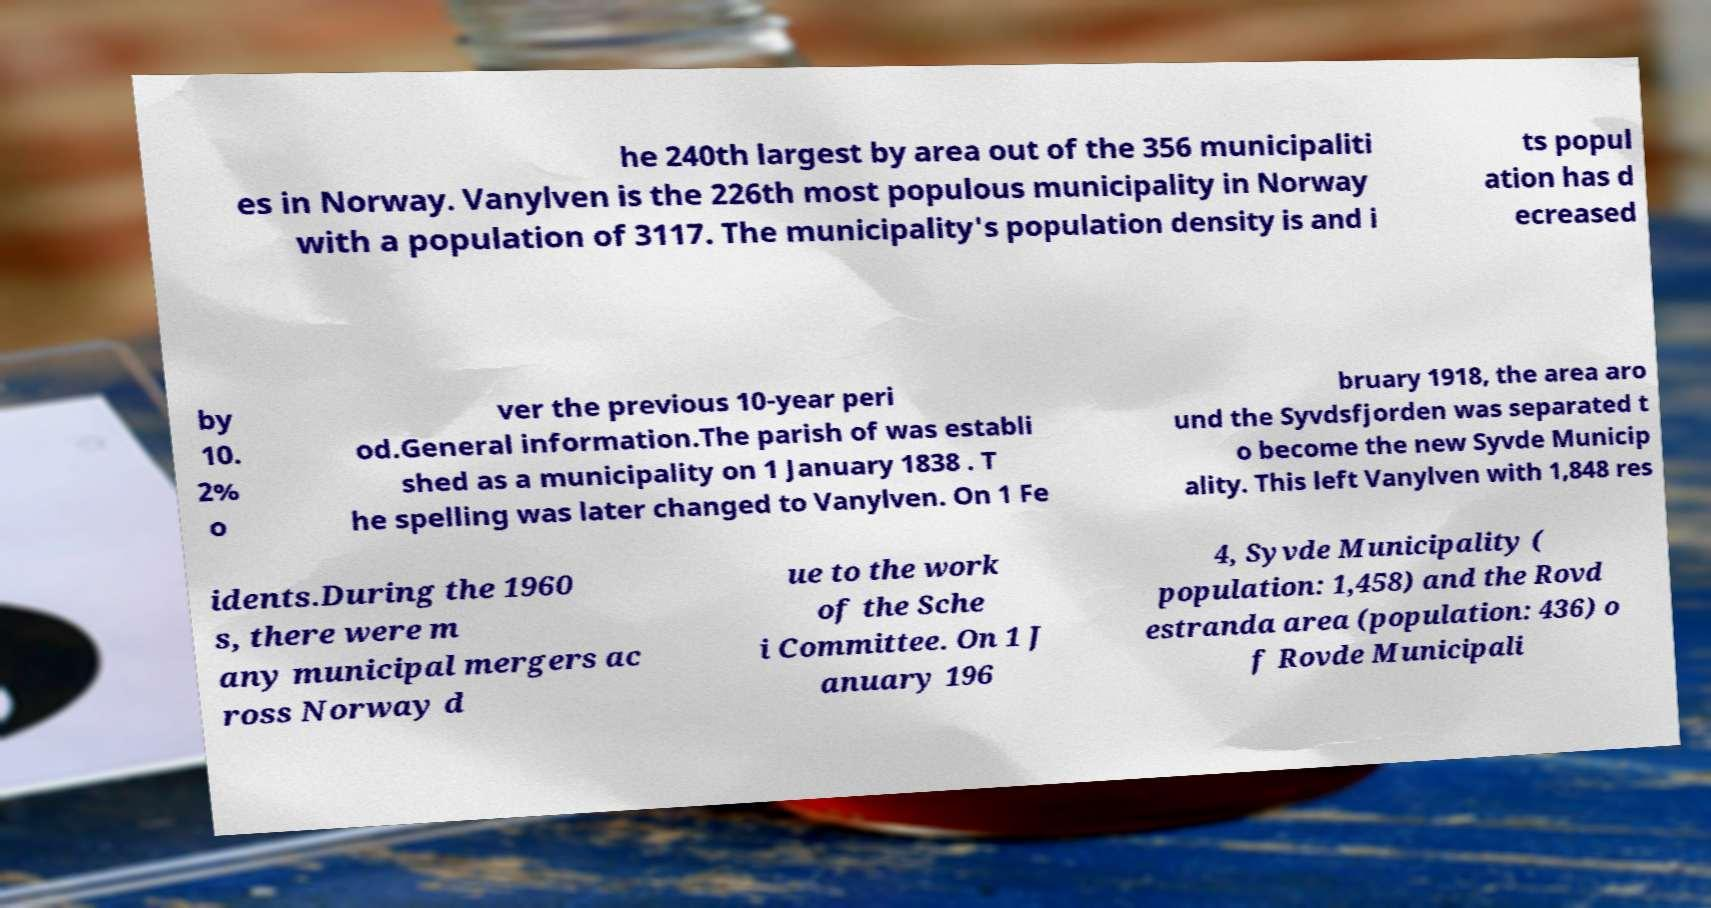Please read and relay the text visible in this image. What does it say? he 240th largest by area out of the 356 municipaliti es in Norway. Vanylven is the 226th most populous municipality in Norway with a population of 3117. The municipality's population density is and i ts popul ation has d ecreased by 10. 2% o ver the previous 10-year peri od.General information.The parish of was establi shed as a municipality on 1 January 1838 . T he spelling was later changed to Vanylven. On 1 Fe bruary 1918, the area aro und the Syvdsfjorden was separated t o become the new Syvde Municip ality. This left Vanylven with 1,848 res idents.During the 1960 s, there were m any municipal mergers ac ross Norway d ue to the work of the Sche i Committee. On 1 J anuary 196 4, Syvde Municipality ( population: 1,458) and the Rovd estranda area (population: 436) o f Rovde Municipali 